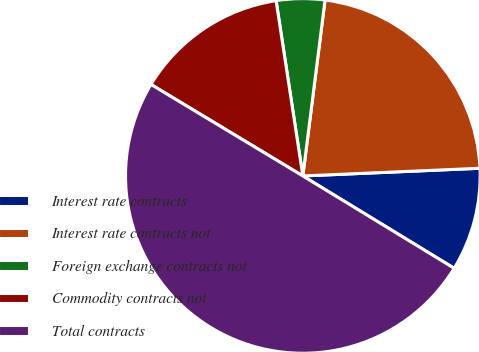<chart> <loc_0><loc_0><loc_500><loc_500><pie_chart><fcel>Interest rate contracts<fcel>Interest rate contracts not<fcel>Foreign exchange contracts not<fcel>Commodity contracts not<fcel>Total contracts<nl><fcel>9.41%<fcel>22.31%<fcel>4.41%<fcel>13.96%<fcel>49.91%<nl></chart> 